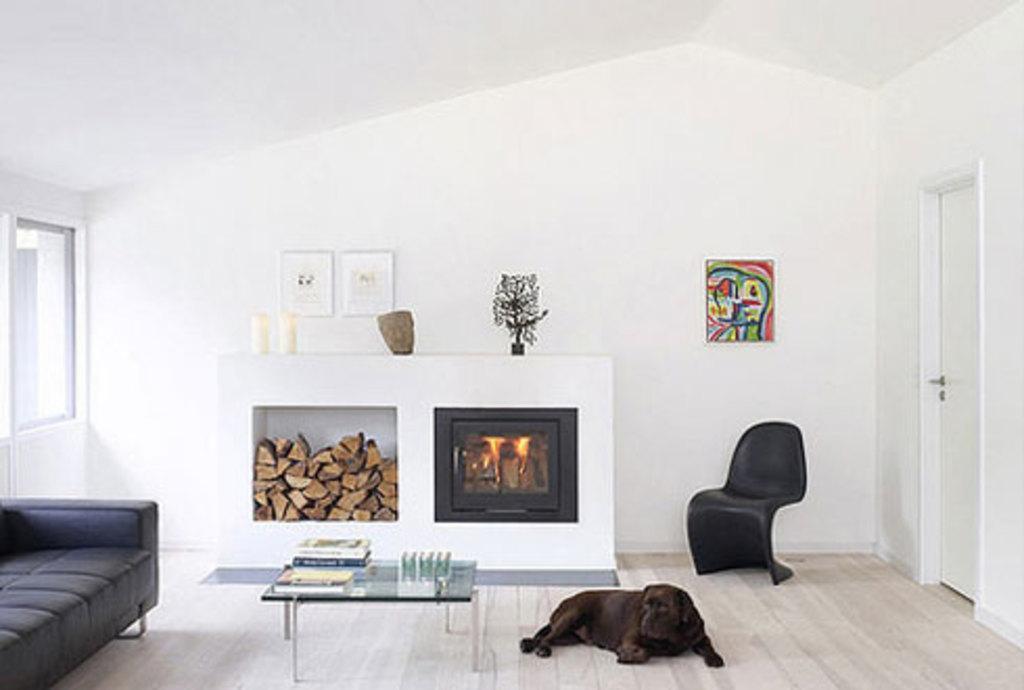Describe this image in one or two sentences. I can see in this image a table, a dog and a couch on the floor. I can also see there is a door, a white color wall with a photo on it and a window. 